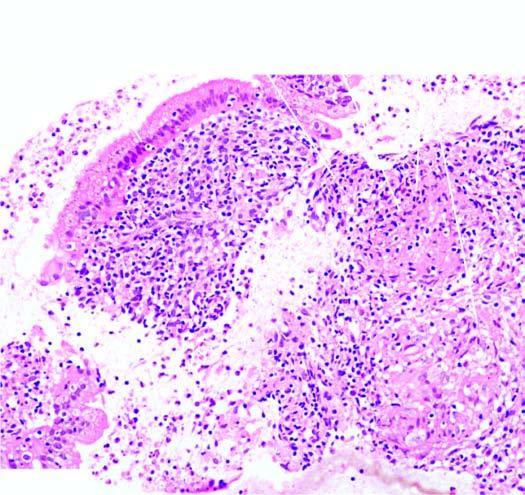what has caseating epithelioid cell granulomas having langhans 'giant cells and peripheral layer of lymphocytes?
Answer the question using a single word or phrase. Stroma 